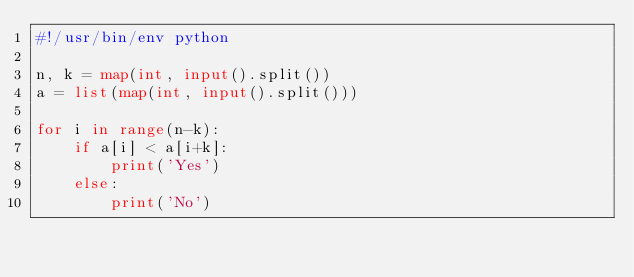Convert code to text. <code><loc_0><loc_0><loc_500><loc_500><_Python_>#!/usr/bin/env python

n, k = map(int, input().split())
a = list(map(int, input().split()))

for i in range(n-k):
    if a[i] < a[i+k]:
        print('Yes')
    else:
        print('No')
</code> 